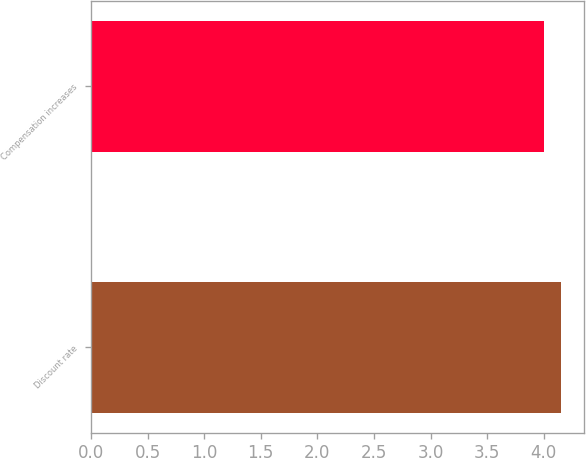Convert chart to OTSL. <chart><loc_0><loc_0><loc_500><loc_500><bar_chart><fcel>Discount rate<fcel>Compensation increases<nl><fcel>4.15<fcel>4<nl></chart> 